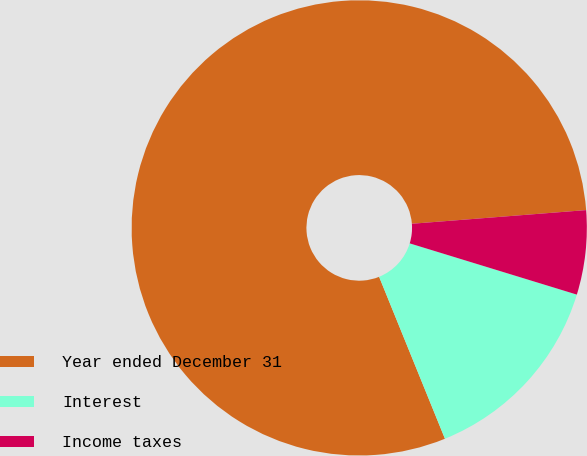<chart> <loc_0><loc_0><loc_500><loc_500><pie_chart><fcel>Year ended December 31<fcel>Interest<fcel>Income taxes<nl><fcel>79.9%<fcel>14.12%<fcel>5.98%<nl></chart> 